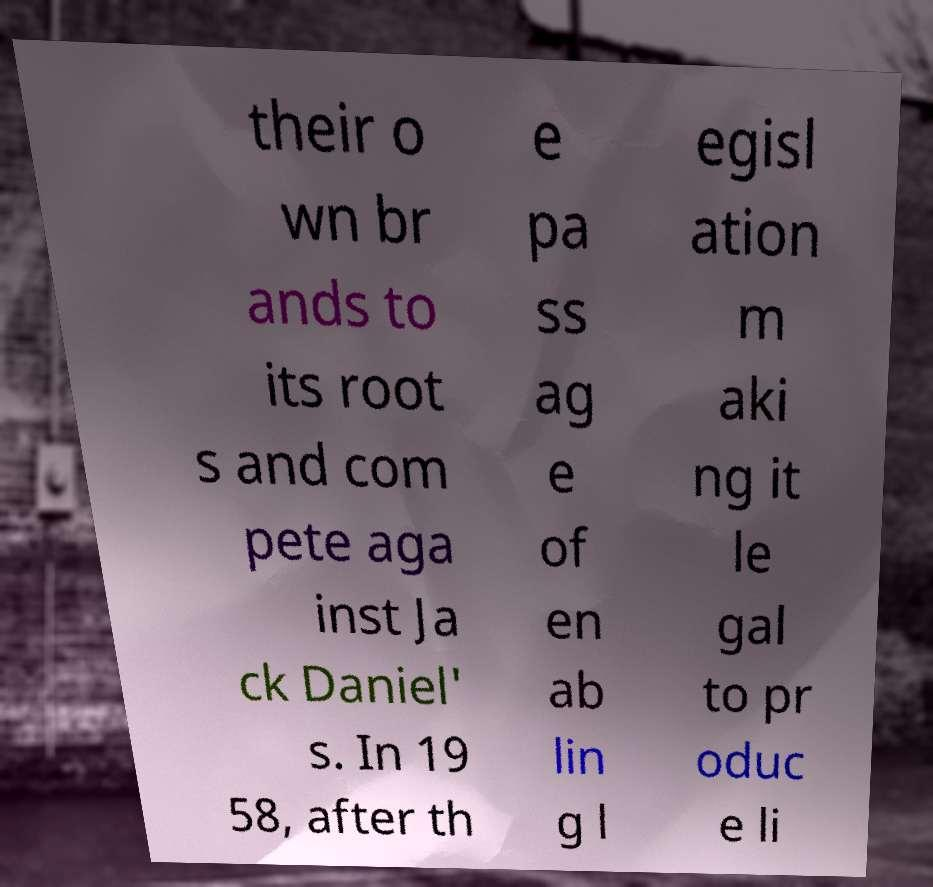Please read and relay the text visible in this image. What does it say? their o wn br ands to its root s and com pete aga inst Ja ck Daniel' s. In 19 58, after th e pa ss ag e of en ab lin g l egisl ation m aki ng it le gal to pr oduc e li 